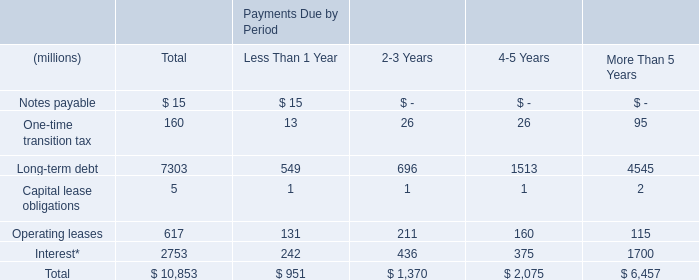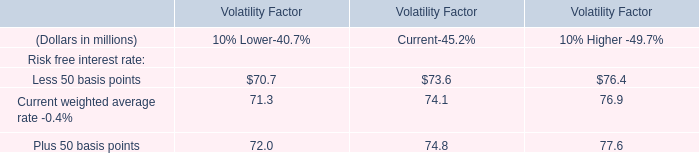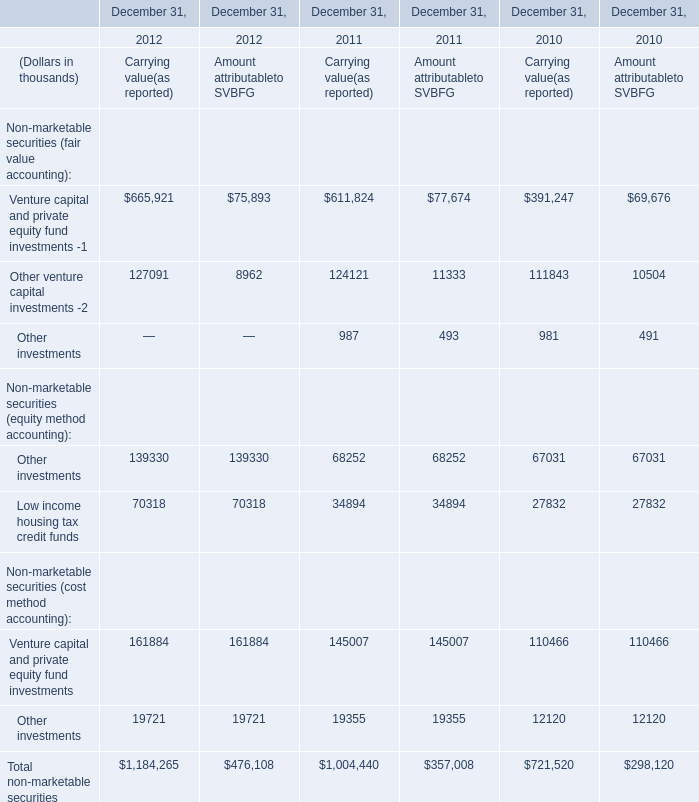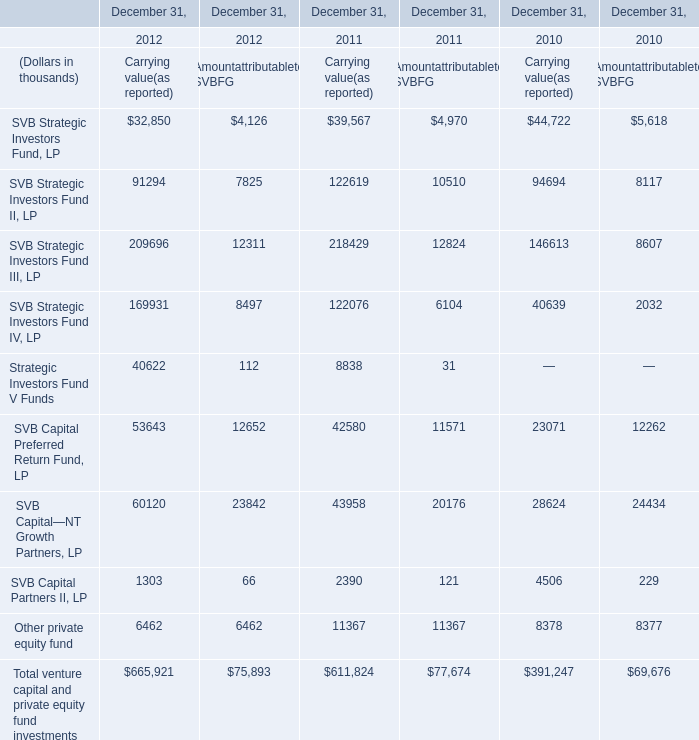What is the sum of SVB Strategic Investors Fund III, LP in the range of 1 and 300000 in 2012 ? (in thousand) 
Computations: (209696 + 12311)
Answer: 222007.0. 